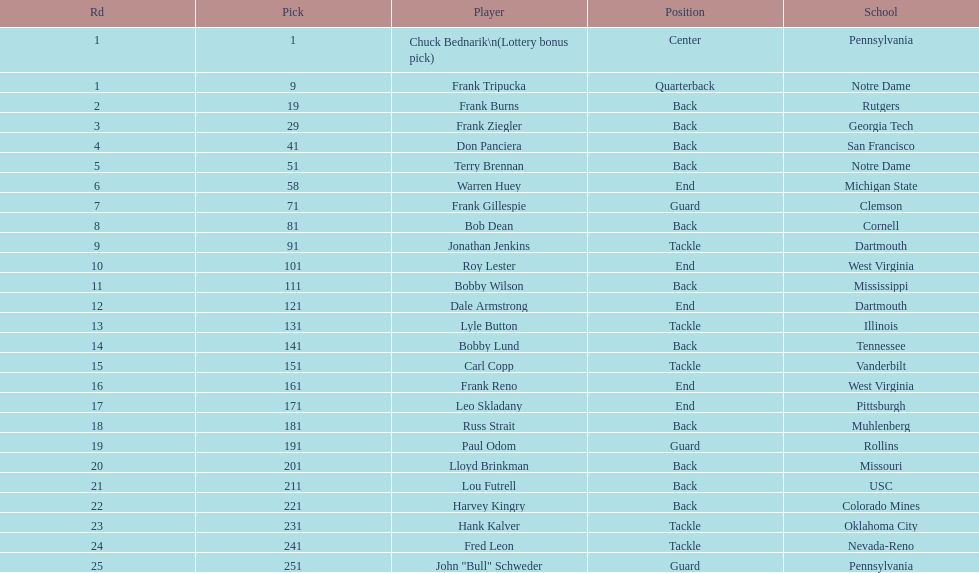Parse the table in full. {'header': ['Rd', 'Pick', 'Player', 'Position', 'School'], 'rows': [['1', '1', 'Chuck Bednarik\\n(Lottery bonus pick)', 'Center', 'Pennsylvania'], ['1', '9', 'Frank Tripucka', 'Quarterback', 'Notre Dame'], ['2', '19', 'Frank Burns', 'Back', 'Rutgers'], ['3', '29', 'Frank Ziegler', 'Back', 'Georgia Tech'], ['4', '41', 'Don Panciera', 'Back', 'San Francisco'], ['5', '51', 'Terry Brennan', 'Back', 'Notre Dame'], ['6', '58', 'Warren Huey', 'End', 'Michigan State'], ['7', '71', 'Frank Gillespie', 'Guard', 'Clemson'], ['8', '81', 'Bob Dean', 'Back', 'Cornell'], ['9', '91', 'Jonathan Jenkins', 'Tackle', 'Dartmouth'], ['10', '101', 'Roy Lester', 'End', 'West Virginia'], ['11', '111', 'Bobby Wilson', 'Back', 'Mississippi'], ['12', '121', 'Dale Armstrong', 'End', 'Dartmouth'], ['13', '131', 'Lyle Button', 'Tackle', 'Illinois'], ['14', '141', 'Bobby Lund', 'Back', 'Tennessee'], ['15', '151', 'Carl Copp', 'Tackle', 'Vanderbilt'], ['16', '161', 'Frank Reno', 'End', 'West Virginia'], ['17', '171', 'Leo Skladany', 'End', 'Pittsburgh'], ['18', '181', 'Russ Strait', 'Back', 'Muhlenberg'], ['19', '191', 'Paul Odom', 'Guard', 'Rollins'], ['20', '201', 'Lloyd Brinkman', 'Back', 'Missouri'], ['21', '211', 'Lou Futrell', 'Back', 'USC'], ['22', '221', 'Harvey Kingry', 'Back', 'Colorado Mines'], ['23', '231', 'Hank Kalver', 'Tackle', 'Oklahoma City'], ['24', '241', 'Fred Leon', 'Tackle', 'Nevada-Reno'], ['25', '251', 'John "Bull" Schweder', 'Guard', 'Pennsylvania']]} Most widespread school Pennsylvania. 